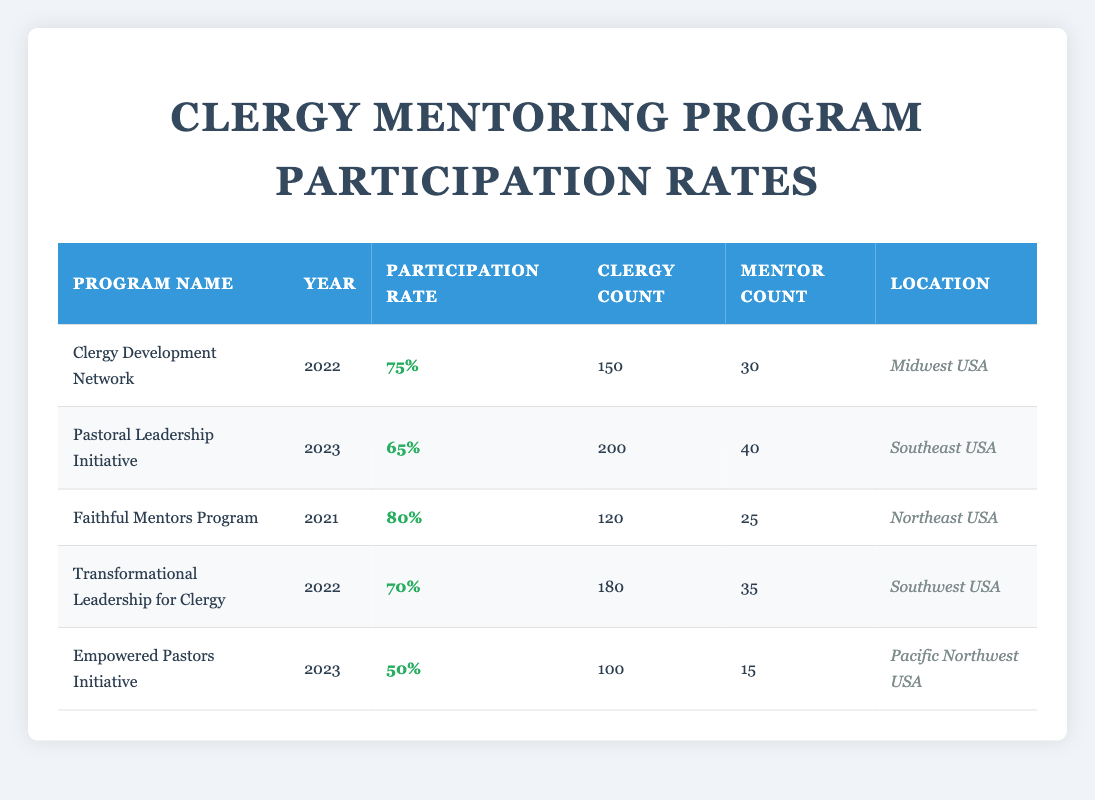What is the participation rate for the Faithful Mentors Program? The participation rate is listed directly in the row for the Faithful Mentors Program, which shows a value of 80%.
Answer: 80% Which program had the highest clergy count in 2023? Looking at the year 2023, there are two programs: Pastoral Leadership Initiative with 200 clergy and Empowered Pastors Initiative with 100 clergy. The one with the highest clergy count is the Pastoral Leadership Initiative.
Answer: Pastoral Leadership Initiative What is the average participation rate across all programs? To find the average participation rate, add the participation rates of all programs (75 + 65 + 80 + 70 + 50 = 410), then divide by the number of programs (410 / 5 = 82).
Answer: 82 Did the Empowered Pastors Initiative have a higher or lower participation rate than the clergy development network? The Empowered Pastors Initiative had a participation rate of 50%, while the Clergy Development Network had a participation rate of 75%. Since 50% is less than 75%, it is lower.
Answer: Lower How many mentors participated in the Transformational Leadership for Clergy program? The number of mentors for this program is provided directly in the table, which states there were 35 mentors involved.
Answer: 35 Is it true that the Faithful Mentors Program was the only program to have a participation rate over 75%? Examining the participation rates, both the Faithful Mentors Program (80%) and the Clergy Development Network (75%) have rates at or above 75%. Therefore, the statement is false.
Answer: False What is the total number of mentors across all programs? To calculate the total number of mentors, add the mentors from each program (30 + 40 + 25 + 35 + 15 = 145). The total number of mentors across all programs is thus 145.
Answer: 145 Which location had the lowest participation rate in mentoring programs? The participation rates for 2023 are 65% in Southeast USA (Pastoral Leadership Initiative) and 50% in Pacific Northwest USA (Empowered Pastors Initiative). The lowest is in Pacific Northwest USA.
Answer: Pacific Northwest USA Which program had more clergy, the Transformational Leadership for Clergy or the Faithful Mentors Program? The Transformational Leadership for Clergy had 180 clergy, while the Faithful Mentors Program had 120 clergy. Since 180 is greater than 120, the Transformational Leadership for Clergy had more clergy.
Answer: Transformational Leadership for Clergy 